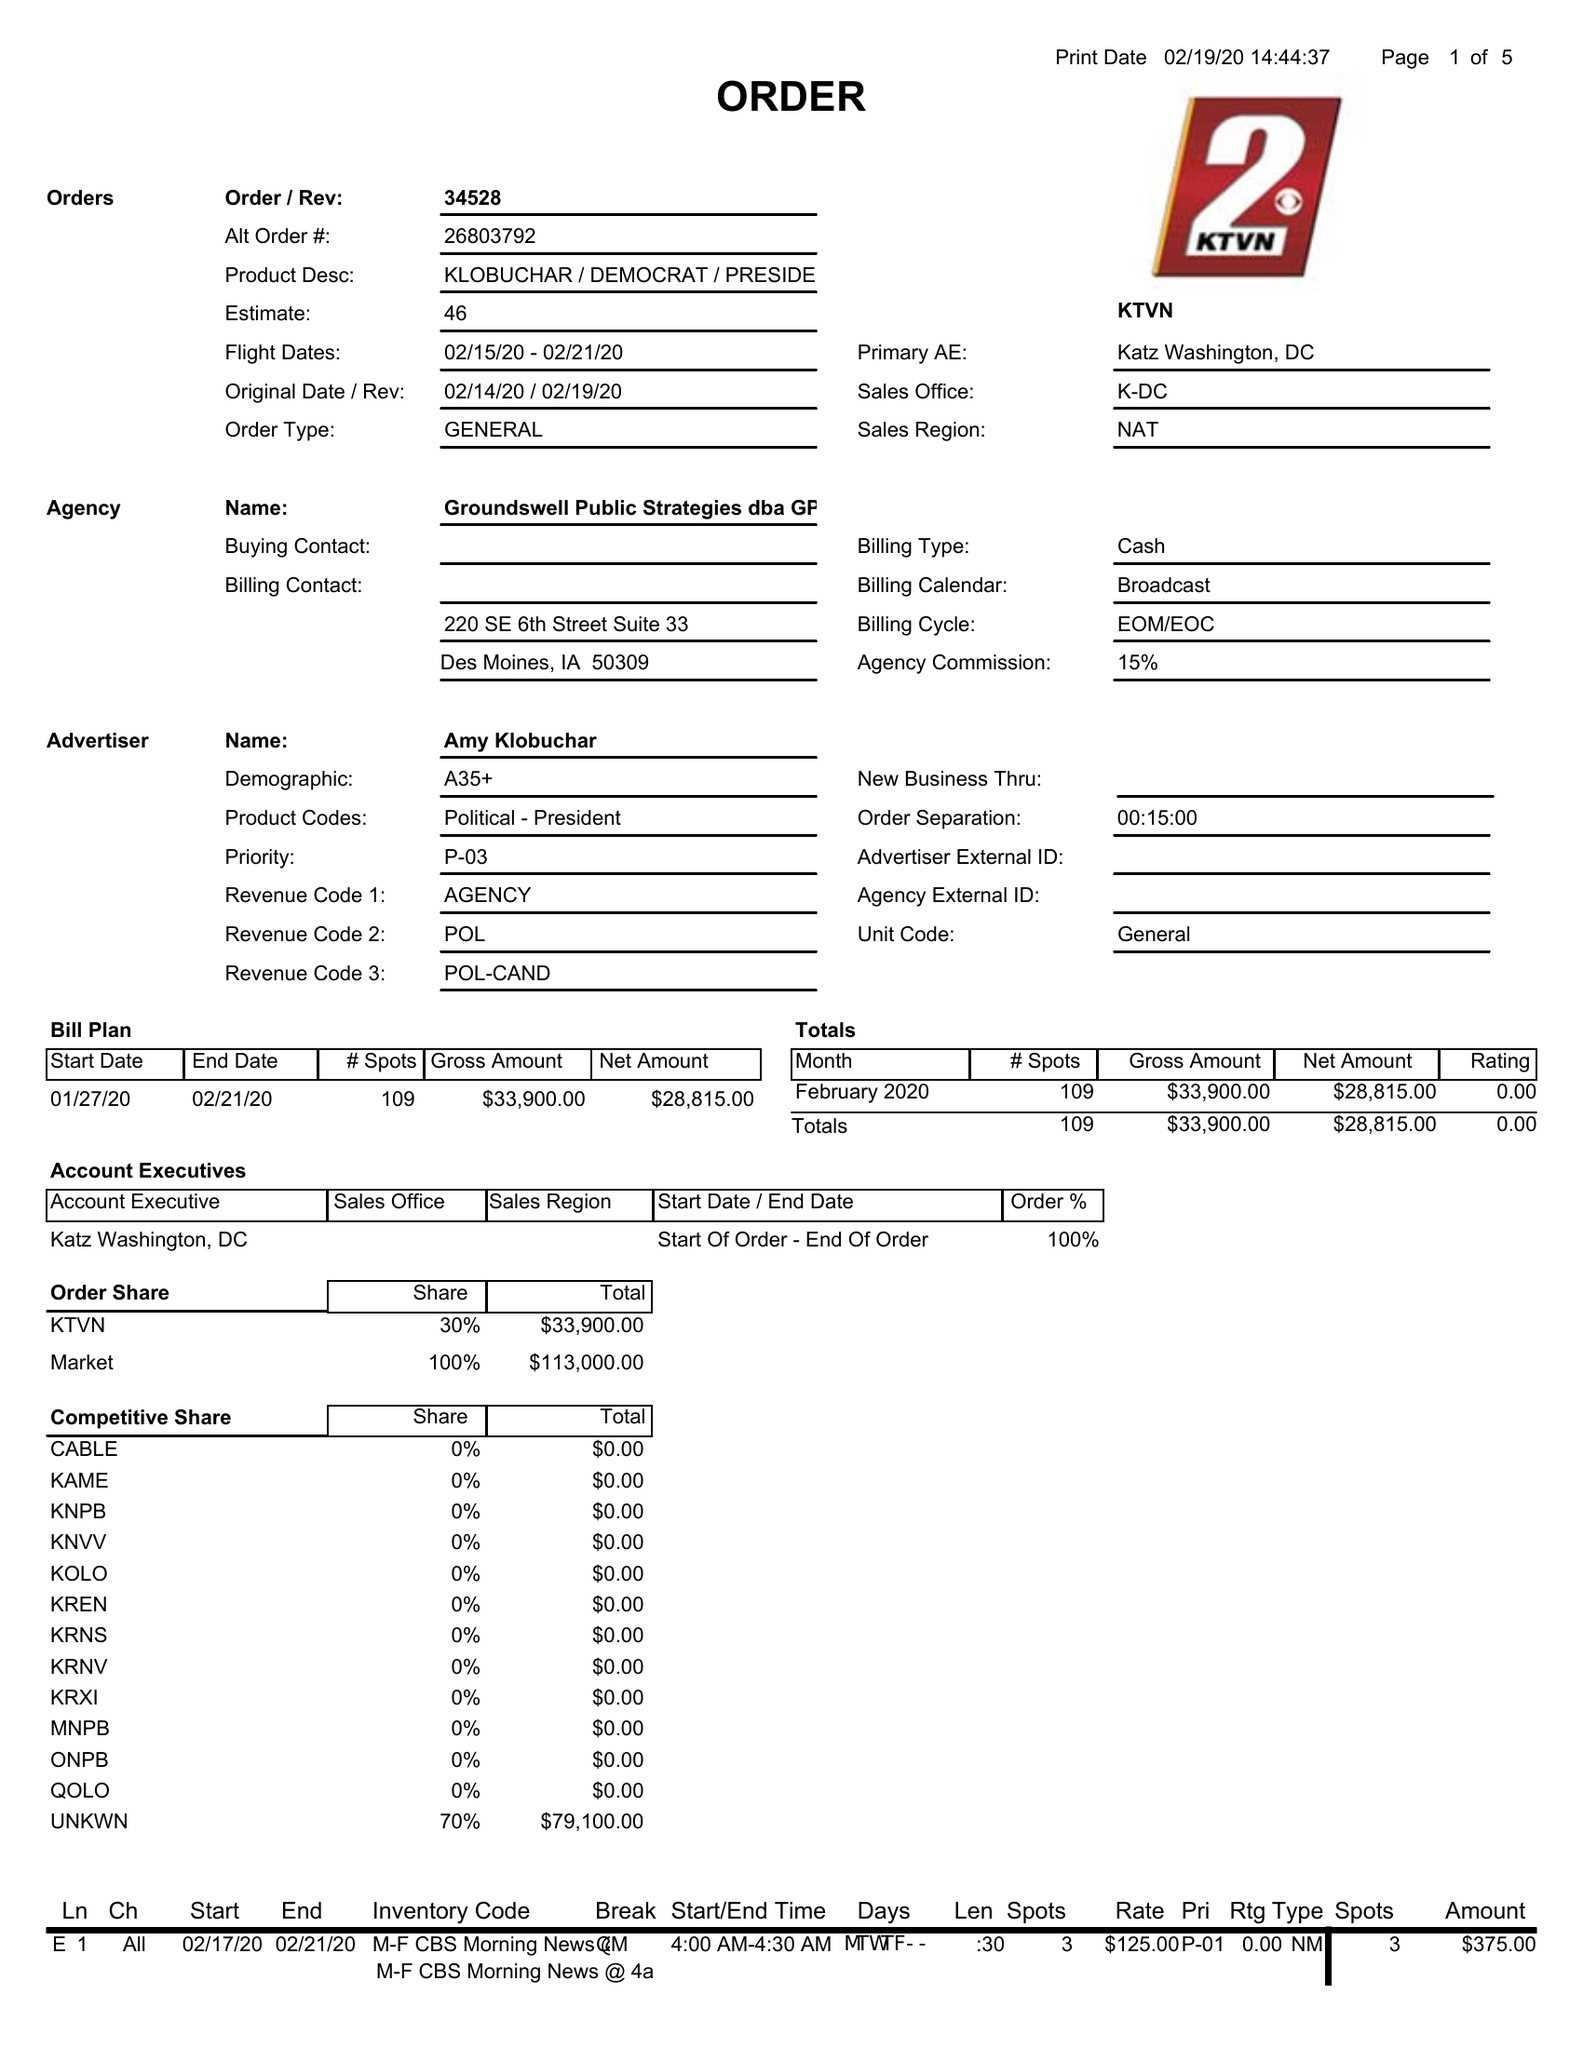What is the value for the advertiser?
Answer the question using a single word or phrase. AMY KLOBUCHAR 